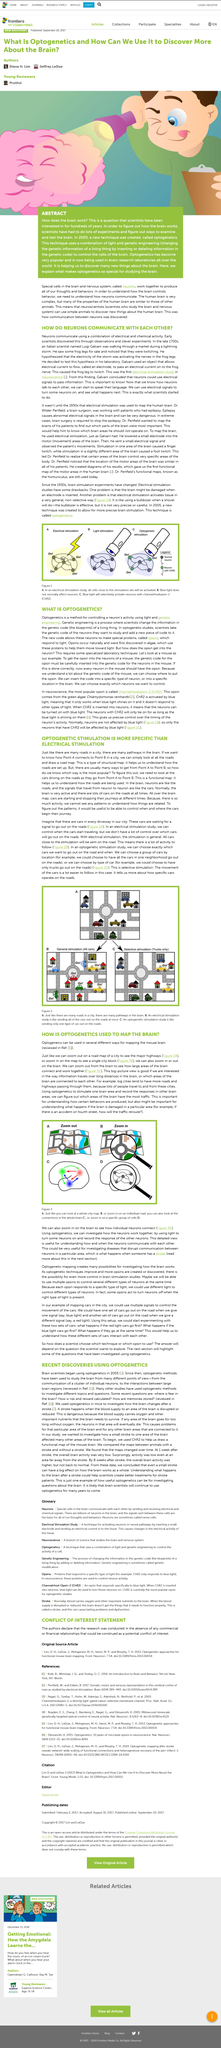Highlight a few significant elements in this photo. Optogenetics has become extremely popular. The abstract mentions that scientists have been interested in the workings of the brain for several hundred years. A new technique was created in the year 2005. 